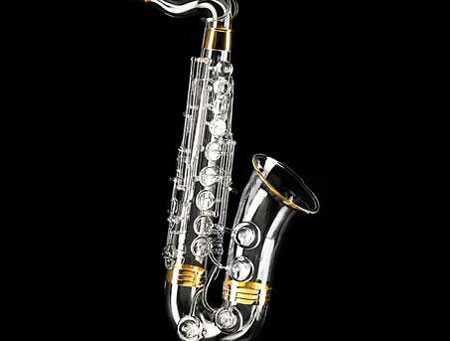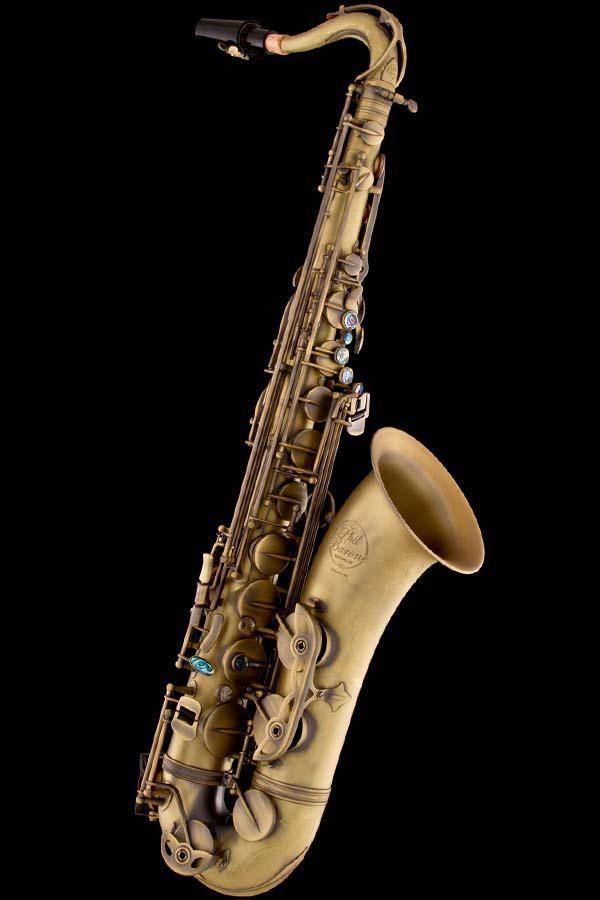The first image is the image on the left, the second image is the image on the right. For the images displayed, is the sentence "At least one of the images contains a silver toned saxophone." factually correct? Answer yes or no. Yes. 